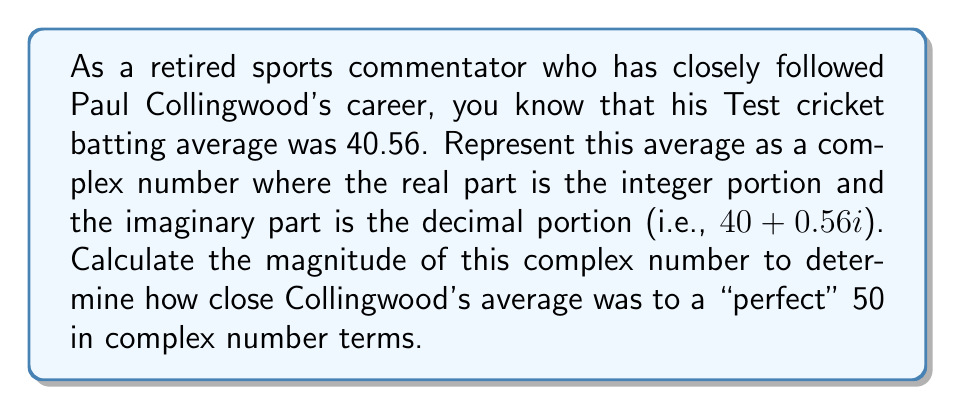Teach me how to tackle this problem. To solve this problem, we need to follow these steps:

1) Represent Collingwood's batting average as a complex number:
   $z = 40 + 0.56i$

2) Recall that the magnitude of a complex number $a + bi$ is given by the formula:
   $|z| = \sqrt{a^2 + b^2}$

3) In this case, $a = 40$ and $b = 0.56$

4) Let's substitute these values into the formula:
   $|z| = \sqrt{40^2 + 0.56^2}$

5) Calculate the squares:
   $|z| = \sqrt{1600 + 0.3136}$

6) Add the values under the square root:
   $|z| = \sqrt{1600.3136}$

7) Calculate the square root:
   $|z| \approx 40.0039$

This result shows that the magnitude of the complex number representing Collingwood's batting average is very close to 40, which is expected given that the imaginary part (0.56) is relatively small compared to the real part (40).
Answer: The magnitude of the complex number representing Paul Collingwood's batting average is approximately 40.0039. 